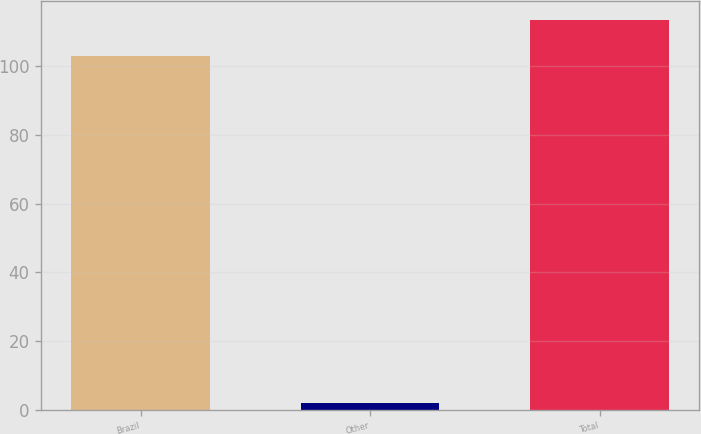Convert chart. <chart><loc_0><loc_0><loc_500><loc_500><bar_chart><fcel>Brazil<fcel>Other<fcel>Total<nl><fcel>103<fcel>2<fcel>113.3<nl></chart> 